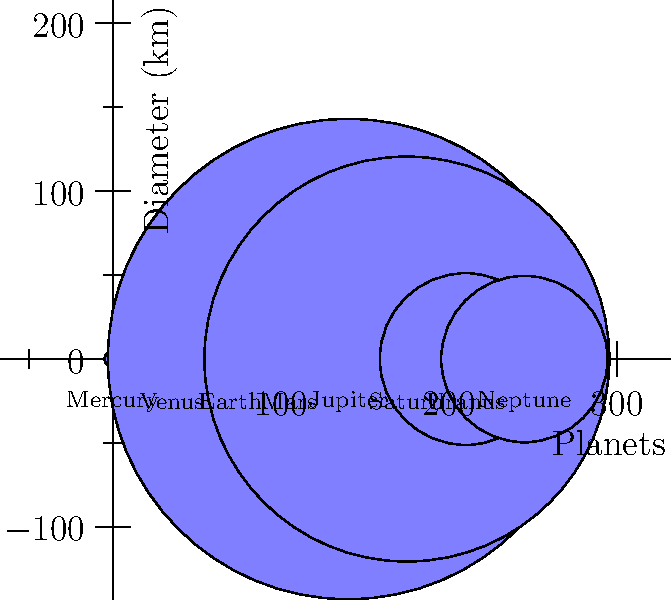As a pharmacist specializing in weight-loss drugs, you understand the importance of proportions and relative sizes. In astronomy, similar principles apply when comparing celestial bodies. Based on the diagram showing the relative sizes of planets in our solar system, which planet has a diameter closest to twice that of Earth? To answer this question, we need to follow these steps:

1. Identify Earth's diameter from the diagram: 12,756 km

2. Calculate twice Earth's diameter:
   $2 \times 12,756 = 25,512$ km

3. Compare this value to the diameters of other planets:
   Mercury: 4,879 km
   Venus: 12,104 km
   Mars: 6,792 km
   Jupiter: 142,984 km
   Saturn: 120,536 km
   Uranus: 51,118 km
   Neptune: 49,528 km

4. Find the planet with the diameter closest to 25,512 km:
   Uranus (51,118 km) and Neptune (49,528 km) are the closest.

5. Determine which of these two is closer to twice Earth's diameter:
   Difference for Uranus: $|51,118 - 25,512| = 25,606$ km
   Difference for Neptune: $|49,528 - 25,512| = 24,016$ km

Neptune has the smaller difference, making it closer to twice Earth's diameter.
Answer: Neptune 